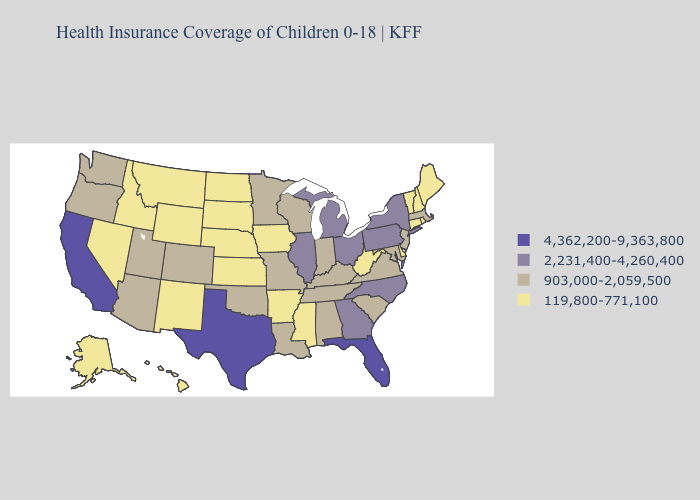What is the value of Wisconsin?
Concise answer only. 903,000-2,059,500. What is the value of Utah?
Short answer required. 903,000-2,059,500. Among the states that border Arkansas , does Louisiana have the highest value?
Write a very short answer. No. What is the value of Mississippi?
Keep it brief. 119,800-771,100. Name the states that have a value in the range 2,231,400-4,260,400?
Concise answer only. Georgia, Illinois, Michigan, New York, North Carolina, Ohio, Pennsylvania. Name the states that have a value in the range 2,231,400-4,260,400?
Keep it brief. Georgia, Illinois, Michigan, New York, North Carolina, Ohio, Pennsylvania. Does the map have missing data?
Write a very short answer. No. Is the legend a continuous bar?
Short answer required. No. What is the value of Oklahoma?
Quick response, please. 903,000-2,059,500. How many symbols are there in the legend?
Write a very short answer. 4. Name the states that have a value in the range 2,231,400-4,260,400?
Write a very short answer. Georgia, Illinois, Michigan, New York, North Carolina, Ohio, Pennsylvania. Name the states that have a value in the range 2,231,400-4,260,400?
Short answer required. Georgia, Illinois, Michigan, New York, North Carolina, Ohio, Pennsylvania. Name the states that have a value in the range 119,800-771,100?
Be succinct. Alaska, Arkansas, Connecticut, Delaware, Hawaii, Idaho, Iowa, Kansas, Maine, Mississippi, Montana, Nebraska, Nevada, New Hampshire, New Mexico, North Dakota, Rhode Island, South Dakota, Vermont, West Virginia, Wyoming. Name the states that have a value in the range 903,000-2,059,500?
Quick response, please. Alabama, Arizona, Colorado, Indiana, Kentucky, Louisiana, Maryland, Massachusetts, Minnesota, Missouri, New Jersey, Oklahoma, Oregon, South Carolina, Tennessee, Utah, Virginia, Washington, Wisconsin. Does Oklahoma have the lowest value in the USA?
Be succinct. No. 